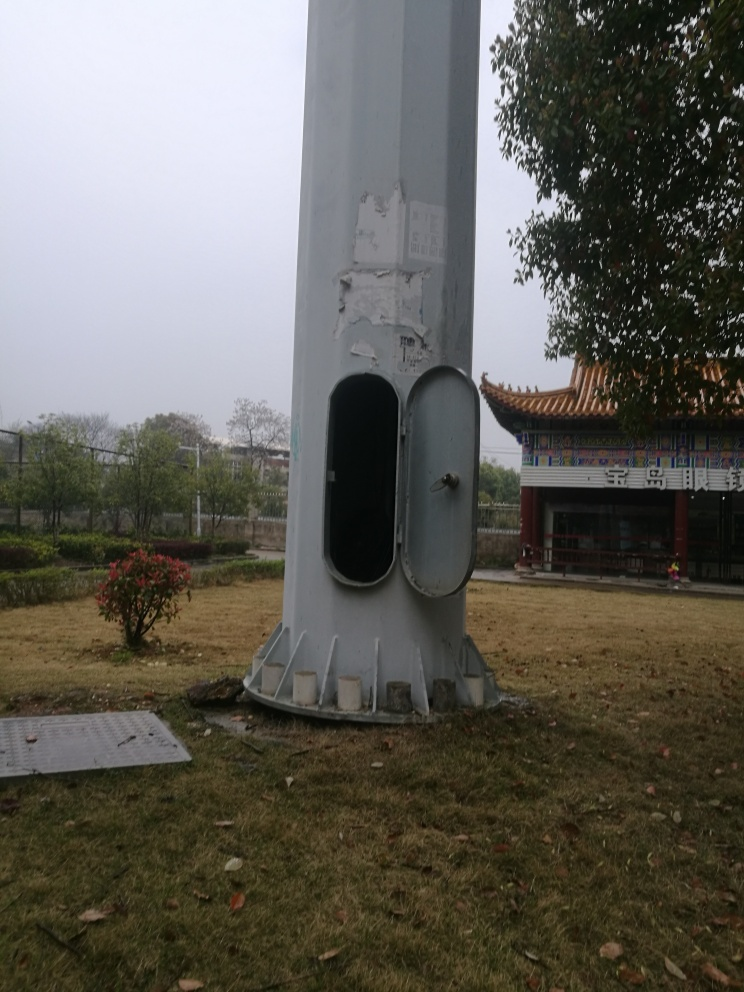Does the image preserve texture details? Texture details in the image seem to be well-preserved, showcasing aspects such as the peeled paint on the column, the rugged surface of the metal door, and the natural pattern of the grass and leaves scattered on the ground. 